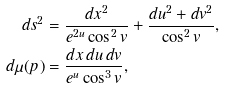<formula> <loc_0><loc_0><loc_500><loc_500>d s ^ { 2 } & = \frac { d x ^ { 2 } } { e ^ { 2 u } \cos ^ { 2 } v } + \frac { d u ^ { 2 } + d v ^ { 2 } } { \cos ^ { 2 } v } , \\ d \mu ( p ) & = \frac { d x \, d u \, d v } { e ^ { u } \cos ^ { 3 } v } ,</formula> 